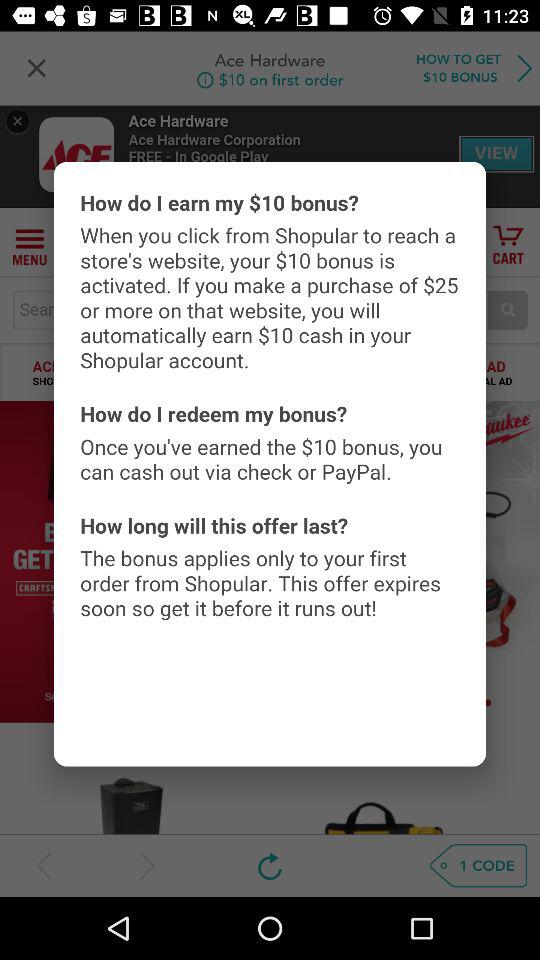What is the amount on first order? The amount on first order is $10. 